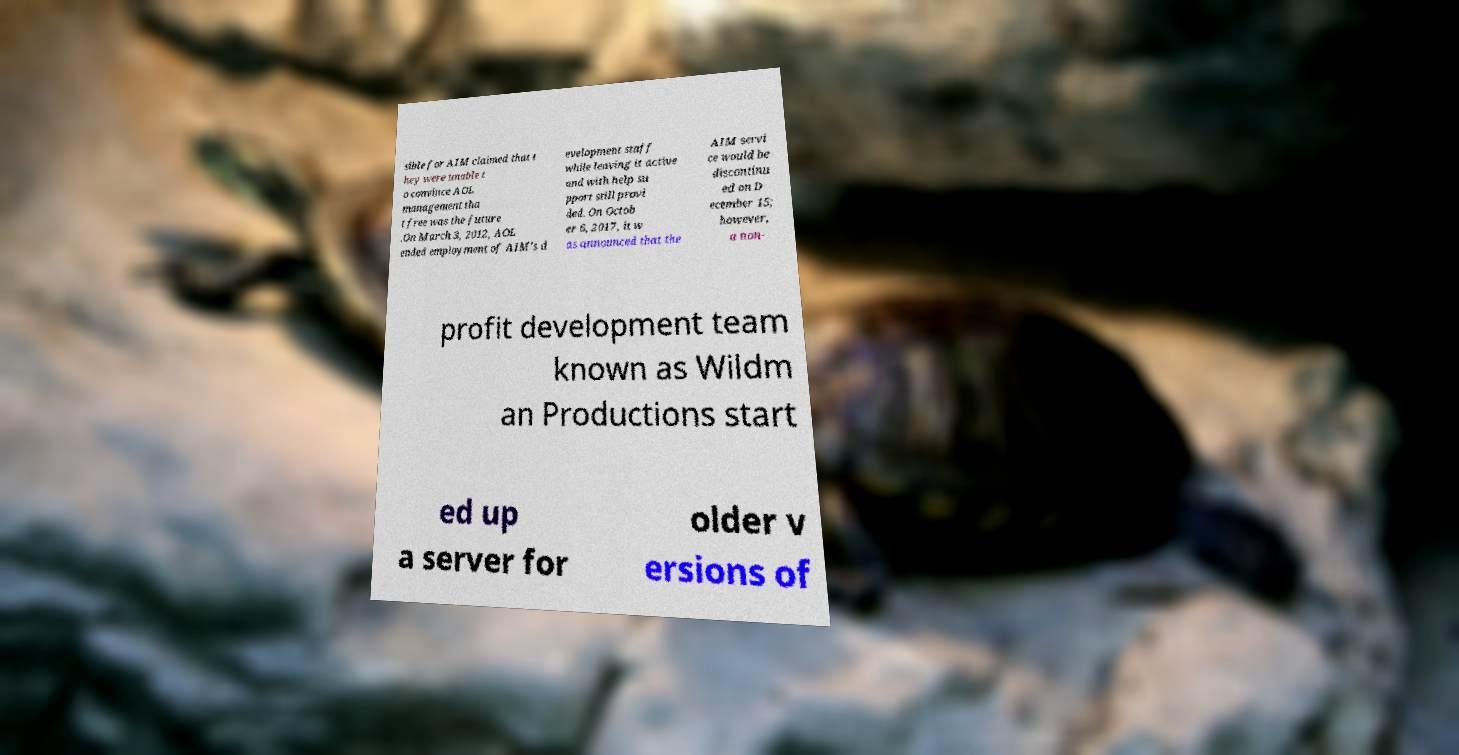Can you accurately transcribe the text from the provided image for me? sible for AIM claimed that t hey were unable t o convince AOL management tha t free was the future .On March 3, 2012, AOL ended employment of AIM's d evelopment staff while leaving it active and with help su pport still provi ded. On Octob er 6, 2017, it w as announced that the AIM servi ce would be discontinu ed on D ecember 15; however, a non- profit development team known as Wildm an Productions start ed up a server for older v ersions of 